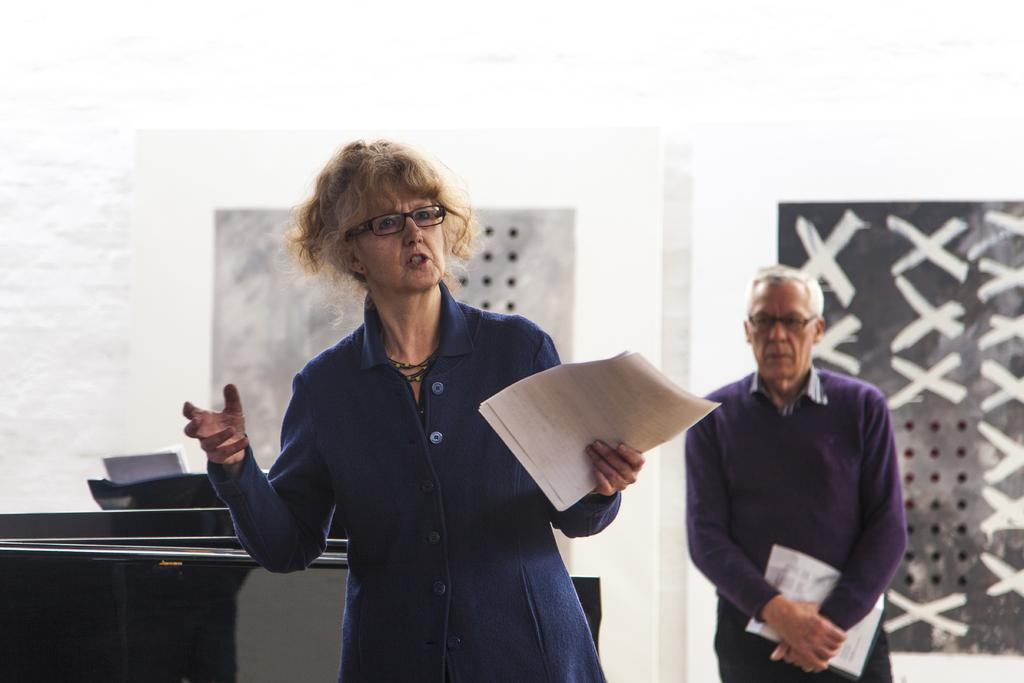What are the people in the image doing? The people in the image are standing on the floor and holding papers in their hands. What can be seen in the background of the image? There are walls visible in the background of the image. What type of beam is being used by the people in the image? There is no beam present in the image; the people are holding papers. How many bags can be seen in the image? There are no bags visible in the image. 